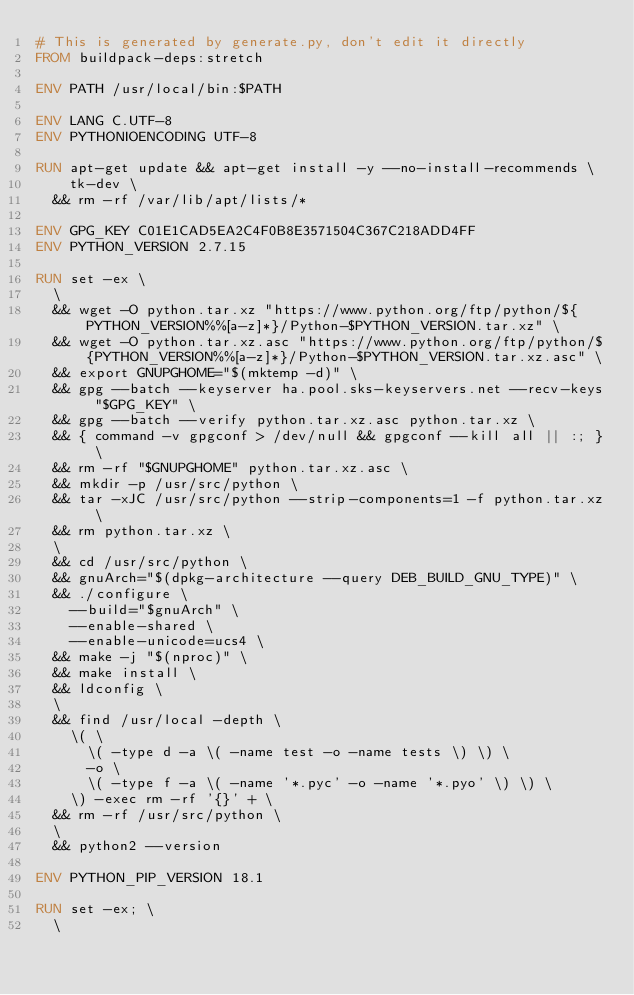Convert code to text. <code><loc_0><loc_0><loc_500><loc_500><_Dockerfile_># This is generated by generate.py, don't edit it directly
FROM buildpack-deps:stretch

ENV PATH /usr/local/bin:$PATH

ENV LANG C.UTF-8
ENV PYTHONIOENCODING UTF-8

RUN apt-get update && apt-get install -y --no-install-recommends \
		tk-dev \
	&& rm -rf /var/lib/apt/lists/*

ENV GPG_KEY C01E1CAD5EA2C4F0B8E3571504C367C218ADD4FF
ENV PYTHON_VERSION 2.7.15

RUN set -ex \
	\
	&& wget -O python.tar.xz "https://www.python.org/ftp/python/${PYTHON_VERSION%%[a-z]*}/Python-$PYTHON_VERSION.tar.xz" \
	&& wget -O python.tar.xz.asc "https://www.python.org/ftp/python/${PYTHON_VERSION%%[a-z]*}/Python-$PYTHON_VERSION.tar.xz.asc" \
	&& export GNUPGHOME="$(mktemp -d)" \
	&& gpg --batch --keyserver ha.pool.sks-keyservers.net --recv-keys "$GPG_KEY" \
	&& gpg --batch --verify python.tar.xz.asc python.tar.xz \
	&& { command -v gpgconf > /dev/null && gpgconf --kill all || :; } \
	&& rm -rf "$GNUPGHOME" python.tar.xz.asc \
	&& mkdir -p /usr/src/python \
	&& tar -xJC /usr/src/python --strip-components=1 -f python.tar.xz \
	&& rm python.tar.xz \
	\
	&& cd /usr/src/python \
	&& gnuArch="$(dpkg-architecture --query DEB_BUILD_GNU_TYPE)" \
	&& ./configure \
		--build="$gnuArch" \
		--enable-shared \
		--enable-unicode=ucs4 \
	&& make -j "$(nproc)" \
	&& make install \
	&& ldconfig \
	\
	&& find /usr/local -depth \
		\( \
			\( -type d -a \( -name test -o -name tests \) \) \
			-o \
			\( -type f -a \( -name '*.pyc' -o -name '*.pyo' \) \) \
		\) -exec rm -rf '{}' + \
	&& rm -rf /usr/src/python \
	\
	&& python2 --version

ENV PYTHON_PIP_VERSION 18.1

RUN set -ex; \
	\</code> 